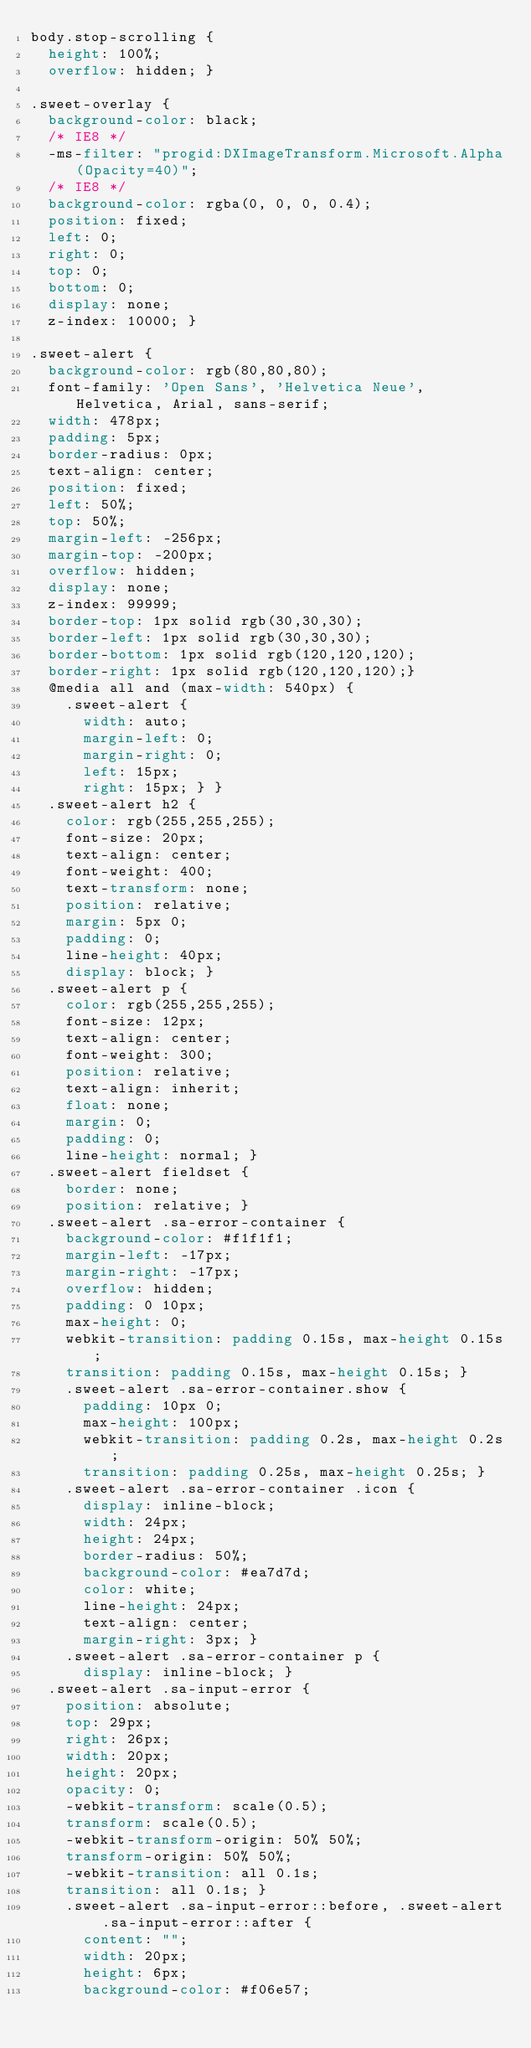Convert code to text. <code><loc_0><loc_0><loc_500><loc_500><_CSS_>body.stop-scrolling {
  height: 100%;
  overflow: hidden; }

.sweet-overlay {
  background-color: black;
  /* IE8 */
  -ms-filter: "progid:DXImageTransform.Microsoft.Alpha(Opacity=40)";
  /* IE8 */
  background-color: rgba(0, 0, 0, 0.4);
  position: fixed;
  left: 0;
  right: 0;
  top: 0;
  bottom: 0;
  display: none;
  z-index: 10000; }

.sweet-alert {
  background-color: rgb(80,80,80);
  font-family: 'Open Sans', 'Helvetica Neue', Helvetica, Arial, sans-serif;
  width: 478px;
  padding: 5px;
  border-radius: 0px;
  text-align: center;
  position: fixed;
  left: 50%;
  top: 50%;
  margin-left: -256px;
  margin-top: -200px;
  overflow: hidden;
  display: none;
  z-index: 99999; 
  border-top: 1px solid rgb(30,30,30);
  border-left: 1px solid rgb(30,30,30);
  border-bottom: 1px solid rgb(120,120,120);
  border-right: 1px solid rgb(120,120,120);}
  @media all and (max-width: 540px) {
    .sweet-alert {
      width: auto;
      margin-left: 0;
      margin-right: 0;
      left: 15px;
      right: 15px; } }
  .sweet-alert h2 {
    color: rgb(255,255,255);
    font-size: 20px;
    text-align: center;
    font-weight: 400;
    text-transform: none;
    position: relative;
    margin: 5px 0;
    padding: 0;
    line-height: 40px;
    display: block; }
  .sweet-alert p {
    color: rgb(255,255,255);
    font-size: 12px;
    text-align: center;
    font-weight: 300;
    position: relative;
    text-align: inherit;
    float: none;
    margin: 0;
    padding: 0;
    line-height: normal; }
  .sweet-alert fieldset {
    border: none;
    position: relative; }
  .sweet-alert .sa-error-container {
    background-color: #f1f1f1;
    margin-left: -17px;
    margin-right: -17px;
    overflow: hidden;
    padding: 0 10px;
    max-height: 0;
    webkit-transition: padding 0.15s, max-height 0.15s;
    transition: padding 0.15s, max-height 0.15s; }
    .sweet-alert .sa-error-container.show {
      padding: 10px 0;
      max-height: 100px;
      webkit-transition: padding 0.2s, max-height 0.2s;
      transition: padding 0.25s, max-height 0.25s; }
    .sweet-alert .sa-error-container .icon {
      display: inline-block;
      width: 24px;
      height: 24px;
      border-radius: 50%;
      background-color: #ea7d7d;
      color: white;
      line-height: 24px;
      text-align: center;
      margin-right: 3px; }
    .sweet-alert .sa-error-container p {
      display: inline-block; }
  .sweet-alert .sa-input-error {
    position: absolute;
    top: 29px;
    right: 26px;
    width: 20px;
    height: 20px;
    opacity: 0;
    -webkit-transform: scale(0.5);
    transform: scale(0.5);
    -webkit-transform-origin: 50% 50%;
    transform-origin: 50% 50%;
    -webkit-transition: all 0.1s;
    transition: all 0.1s; }
    .sweet-alert .sa-input-error::before, .sweet-alert .sa-input-error::after {
      content: "";
      width: 20px;
      height: 6px;
      background-color: #f06e57;</code> 